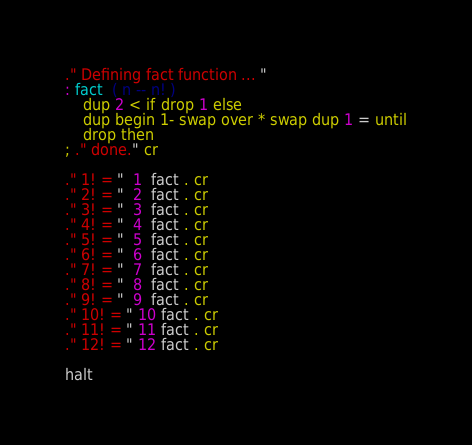<code> <loc_0><loc_0><loc_500><loc_500><_Forth_>
." Defining fact function ... "
: fact  ( n -- n! )
	dup 2 < if drop 1 else
	dup begin 1- swap over * swap dup 1 = until
	drop then
; ." done." cr

." 1! = "  1  fact . cr
." 2! = "  2  fact . cr
." 3! = "  3  fact . cr
." 4! = "  4  fact . cr
." 5! = "  5  fact . cr
." 6! = "  6  fact . cr
." 7! = "  7  fact . cr
." 8! = "  8  fact . cr
." 9! = "  9  fact . cr
." 10! = " 10 fact . cr
." 11! = " 11 fact . cr
." 12! = " 12 fact . cr

halt
</code> 